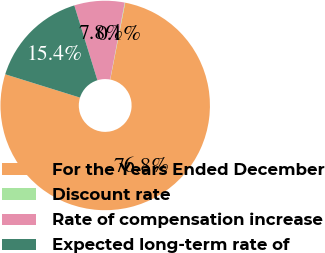<chart> <loc_0><loc_0><loc_500><loc_500><pie_chart><fcel>For the Years Ended December<fcel>Discount rate<fcel>Rate of compensation increase<fcel>Expected long-term rate of<nl><fcel>76.75%<fcel>0.08%<fcel>7.75%<fcel>15.42%<nl></chart> 